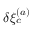<formula> <loc_0><loc_0><loc_500><loc_500>\delta \xi _ { c } ^ { ( a ) }</formula> 